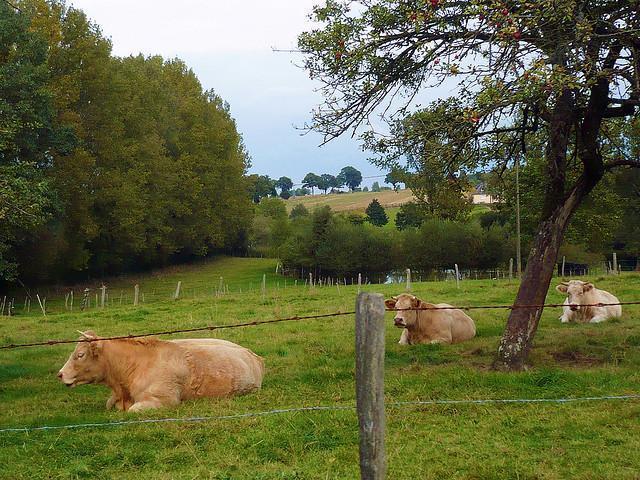What is strung on the fence to keep the cows in?
Select the accurate answer and provide justification: `Answer: choice
Rationale: srationale.`
Options: Wood, wire, thorns, metal. Answer: wire.
Rationale: Cows lay in the grass behind a fence with wood pools and silver line strung between them. 